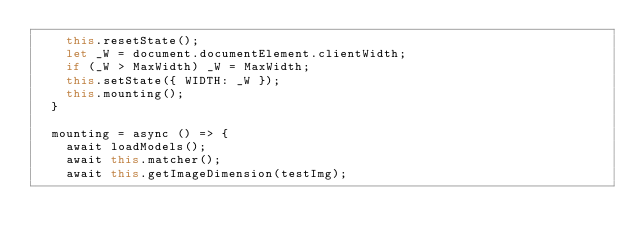<code> <loc_0><loc_0><loc_500><loc_500><_JavaScript_>    this.resetState();
    let _W = document.documentElement.clientWidth;
    if (_W > MaxWidth) _W = MaxWidth;
    this.setState({ WIDTH: _W });
    this.mounting();
  }

  mounting = async () => {
    await loadModels();
    await this.matcher();
    await this.getImageDimension(testImg);</code> 